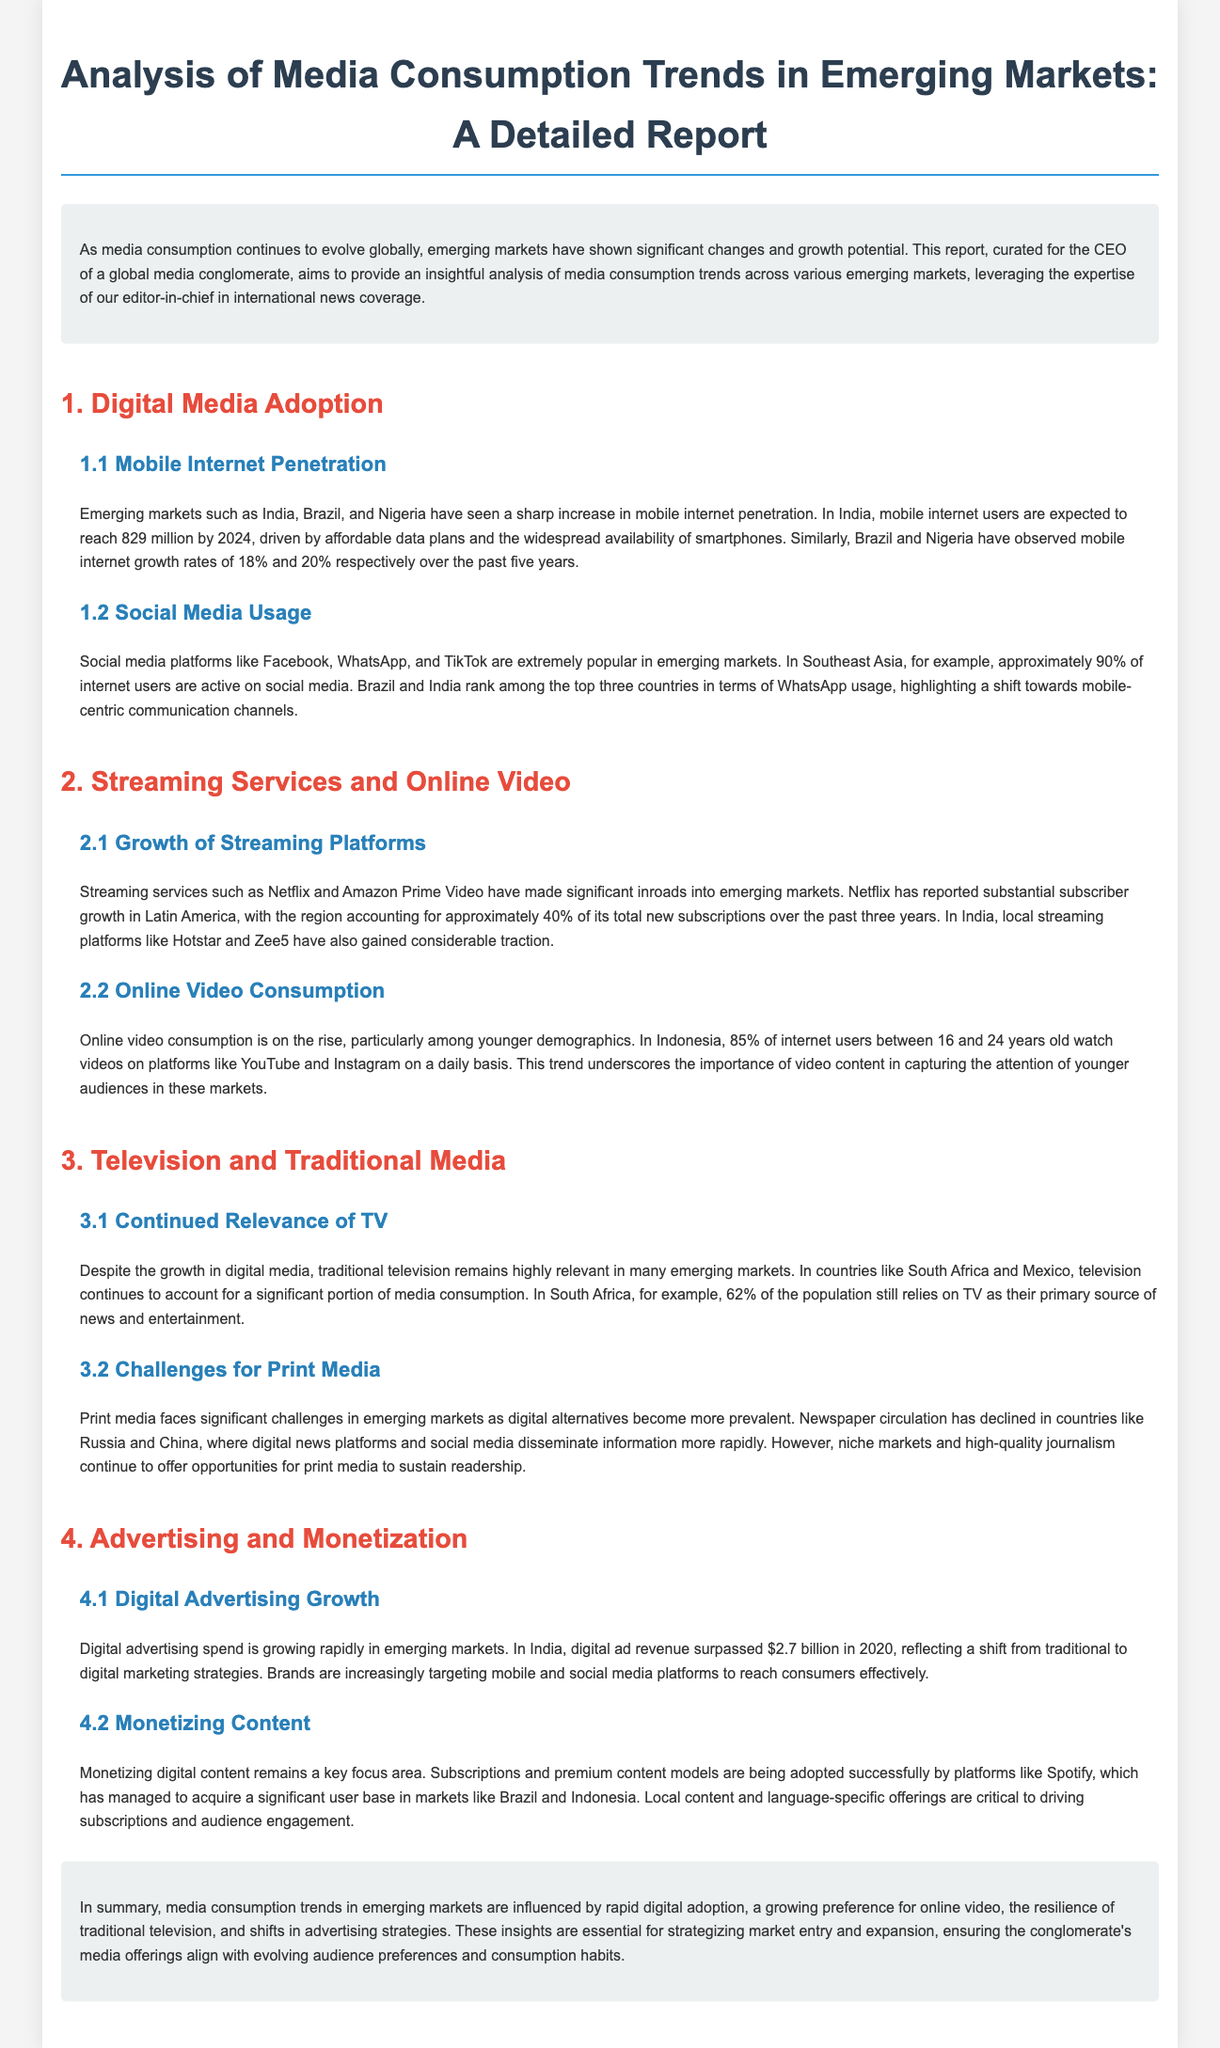What is the projected number of mobile internet users in India by 2024? The document states that mobile internet users in India are expected to reach 829 million by 2024.
Answer: 829 million Which country has the highest mobile internet growth rate according to the document? According to the document, Nigeria has observed a growth rate of 20% over the past five years, the highest mentioned.
Answer: Nigeria What percentage of Southeast Asia's internet users are active on social media? The report mentions that approximately 90% of internet users in Southeast Asia are active on social media.
Answer: 90% How much of Netflix's new subscriptions come from Latin America? The document indicates that Latin America accounts for approximately 40% of Netflix's total new subscriptions over the past three years.
Answer: 40% What is the percentage of South Africa's population that relies on TV as their primary source of news and entertainment? In South Africa, 62% of the population still relies on TV.
Answer: 62% Which streaming platform gained considerable traction in India? The document mentions local streaming platforms like Hotstar and Zee5 have gained considerable traction in India.
Answer: Hotstar and Zee5 What is the digital ad revenue in India for 2020? The document states that digital ad revenue surpassed $2.7 billion in India in 2020.
Answer: $2.7 billion What type of offerings are critical for driving subscriptions according to the document? The report highlights that local content and language-specific offerings are critical to driving subscriptions.
Answer: Local content and language-specific offerings 